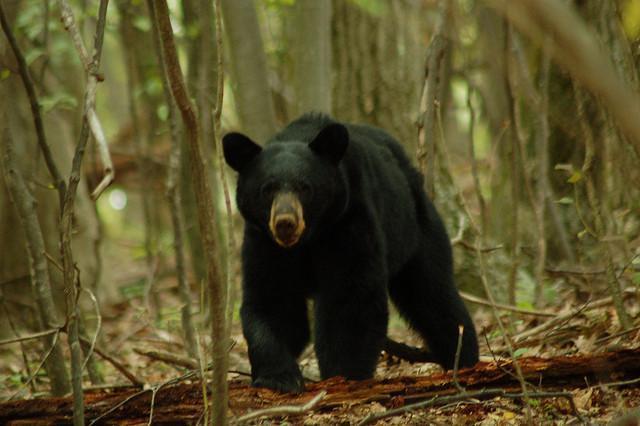How many people are in the raft?
Give a very brief answer. 0. 